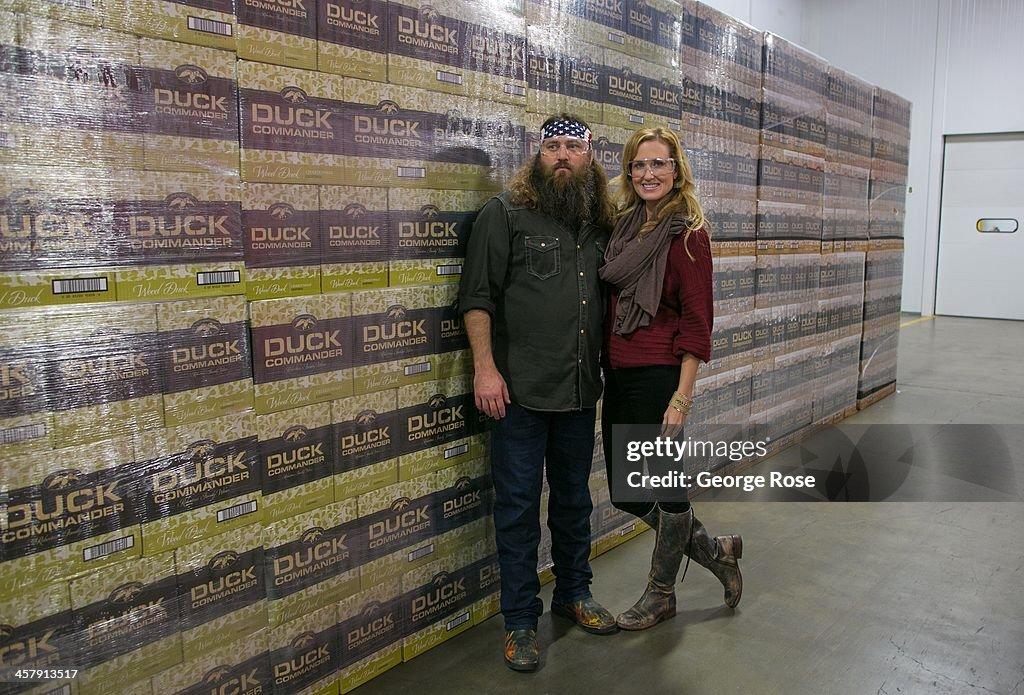What emotions might the individuals in the image be feeling given their body language and surroundings? The individuals appear to be feeling a sense of pride and accomplishment. The man’s relaxed posture and the woman’s smile suggest they are both comfortable and pleased to be in front of a large stockpile of Duck Commander products. This setup may indicate they take pride in their work and are confident in the quality and success of their brand. Apart from hunting, what other activities might the brand Duck Commander be involved in? Besides their involvement in the hunting industry, the Duck Commander brand might also engage in outdoor activities and lifestyle sectors. Given their branding and image, it's plausible they also cater to fishing, camping, and outdoor adventure enthusiasts. Moreover, they could be involved in producing media content such as hunting shows, tutorials, and documentaries that promote an outdoor lifestyle. What roles might these individuals have within the company? The individuals could hold various significant roles within the company. The man, with his relaxed yet confident stance, might be a senior figure like a founder, CEO, or head of operations, overseeing the production and strategic decisions. The woman, with her approachable demeanor, could be in a role such as marketing director, public relations officer, or even co-owner, responsible for promoting the brand and managing customer relationships. Their presence together suggests a collaborative partnership in driving the business forward. 